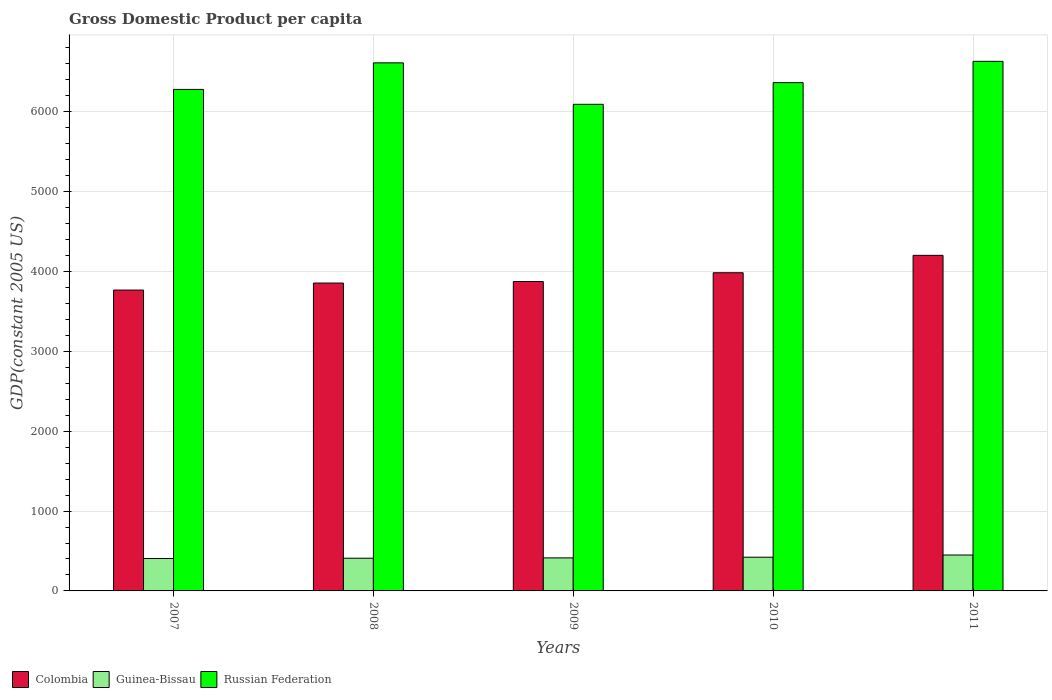How many bars are there on the 2nd tick from the right?
Your answer should be very brief. 3. What is the label of the 3rd group of bars from the left?
Your answer should be very brief. 2009. What is the GDP per capita in Guinea-Bissau in 2009?
Keep it short and to the point. 413.72. Across all years, what is the maximum GDP per capita in Russian Federation?
Your answer should be compact. 6631.46. Across all years, what is the minimum GDP per capita in Colombia?
Give a very brief answer. 3767.33. What is the total GDP per capita in Guinea-Bissau in the graph?
Make the answer very short. 2100.59. What is the difference between the GDP per capita in Colombia in 2008 and that in 2011?
Offer a very short reply. -346.98. What is the difference between the GDP per capita in Colombia in 2007 and the GDP per capita in Guinea-Bissau in 2009?
Offer a terse response. 3353.61. What is the average GDP per capita in Russian Federation per year?
Offer a very short reply. 6396.62. In the year 2010, what is the difference between the GDP per capita in Guinea-Bissau and GDP per capita in Colombia?
Keep it short and to the point. -3562.12. In how many years, is the GDP per capita in Russian Federation greater than 4600 US$?
Your response must be concise. 5. What is the ratio of the GDP per capita in Guinea-Bissau in 2007 to that in 2011?
Offer a terse response. 0.9. Is the difference between the GDP per capita in Guinea-Bissau in 2007 and 2011 greater than the difference between the GDP per capita in Colombia in 2007 and 2011?
Ensure brevity in your answer.  Yes. What is the difference between the highest and the second highest GDP per capita in Guinea-Bissau?
Offer a very short reply. 27.3. What is the difference between the highest and the lowest GDP per capita in Colombia?
Keep it short and to the point. 434.81. What does the 2nd bar from the left in 2009 represents?
Keep it short and to the point. Guinea-Bissau. What does the 2nd bar from the right in 2009 represents?
Make the answer very short. Guinea-Bissau. Is it the case that in every year, the sum of the GDP per capita in Colombia and GDP per capita in Russian Federation is greater than the GDP per capita in Guinea-Bissau?
Make the answer very short. Yes. How many bars are there?
Keep it short and to the point. 15. How many years are there in the graph?
Ensure brevity in your answer.  5. Does the graph contain any zero values?
Provide a succinct answer. No. How are the legend labels stacked?
Provide a succinct answer. Horizontal. What is the title of the graph?
Give a very brief answer. Gross Domestic Product per capita. Does "Malta" appear as one of the legend labels in the graph?
Ensure brevity in your answer.  No. What is the label or title of the X-axis?
Offer a very short reply. Years. What is the label or title of the Y-axis?
Offer a very short reply. GDP(constant 2005 US). What is the GDP(constant 2005 US) of Colombia in 2007?
Provide a succinct answer. 3767.33. What is the GDP(constant 2005 US) in Guinea-Bissau in 2007?
Your response must be concise. 405.66. What is the GDP(constant 2005 US) in Russian Federation in 2007?
Keep it short and to the point. 6280.15. What is the GDP(constant 2005 US) of Colombia in 2008?
Your response must be concise. 3855.16. What is the GDP(constant 2005 US) of Guinea-Bissau in 2008?
Your response must be concise. 409.56. What is the GDP(constant 2005 US) of Russian Federation in 2008?
Give a very brief answer. 6612.63. What is the GDP(constant 2005 US) in Colombia in 2009?
Your answer should be very brief. 3874.43. What is the GDP(constant 2005 US) in Guinea-Bissau in 2009?
Keep it short and to the point. 413.72. What is the GDP(constant 2005 US) in Russian Federation in 2009?
Keep it short and to the point. 6093.63. What is the GDP(constant 2005 US) of Colombia in 2010?
Your response must be concise. 3984.29. What is the GDP(constant 2005 US) in Guinea-Bissau in 2010?
Keep it short and to the point. 422.17. What is the GDP(constant 2005 US) in Russian Federation in 2010?
Ensure brevity in your answer.  6365.21. What is the GDP(constant 2005 US) in Colombia in 2011?
Keep it short and to the point. 4202.14. What is the GDP(constant 2005 US) of Guinea-Bissau in 2011?
Your response must be concise. 449.48. What is the GDP(constant 2005 US) of Russian Federation in 2011?
Your answer should be compact. 6631.46. Across all years, what is the maximum GDP(constant 2005 US) of Colombia?
Offer a very short reply. 4202.14. Across all years, what is the maximum GDP(constant 2005 US) in Guinea-Bissau?
Provide a succinct answer. 449.48. Across all years, what is the maximum GDP(constant 2005 US) of Russian Federation?
Offer a very short reply. 6631.46. Across all years, what is the minimum GDP(constant 2005 US) of Colombia?
Keep it short and to the point. 3767.33. Across all years, what is the minimum GDP(constant 2005 US) of Guinea-Bissau?
Make the answer very short. 405.66. Across all years, what is the minimum GDP(constant 2005 US) of Russian Federation?
Your answer should be very brief. 6093.63. What is the total GDP(constant 2005 US) of Colombia in the graph?
Your answer should be very brief. 1.97e+04. What is the total GDP(constant 2005 US) in Guinea-Bissau in the graph?
Keep it short and to the point. 2100.59. What is the total GDP(constant 2005 US) in Russian Federation in the graph?
Keep it short and to the point. 3.20e+04. What is the difference between the GDP(constant 2005 US) of Colombia in 2007 and that in 2008?
Make the answer very short. -87.83. What is the difference between the GDP(constant 2005 US) of Guinea-Bissau in 2007 and that in 2008?
Ensure brevity in your answer.  -3.9. What is the difference between the GDP(constant 2005 US) of Russian Federation in 2007 and that in 2008?
Your answer should be very brief. -332.48. What is the difference between the GDP(constant 2005 US) in Colombia in 2007 and that in 2009?
Provide a short and direct response. -107.1. What is the difference between the GDP(constant 2005 US) of Guinea-Bissau in 2007 and that in 2009?
Offer a terse response. -8.05. What is the difference between the GDP(constant 2005 US) of Russian Federation in 2007 and that in 2009?
Offer a very short reply. 186.52. What is the difference between the GDP(constant 2005 US) in Colombia in 2007 and that in 2010?
Your response must be concise. -216.96. What is the difference between the GDP(constant 2005 US) in Guinea-Bissau in 2007 and that in 2010?
Keep it short and to the point. -16.51. What is the difference between the GDP(constant 2005 US) of Russian Federation in 2007 and that in 2010?
Offer a very short reply. -85.07. What is the difference between the GDP(constant 2005 US) of Colombia in 2007 and that in 2011?
Keep it short and to the point. -434.81. What is the difference between the GDP(constant 2005 US) of Guinea-Bissau in 2007 and that in 2011?
Offer a terse response. -43.82. What is the difference between the GDP(constant 2005 US) of Russian Federation in 2007 and that in 2011?
Provide a short and direct response. -351.32. What is the difference between the GDP(constant 2005 US) of Colombia in 2008 and that in 2009?
Make the answer very short. -19.27. What is the difference between the GDP(constant 2005 US) in Guinea-Bissau in 2008 and that in 2009?
Provide a succinct answer. -4.16. What is the difference between the GDP(constant 2005 US) of Russian Federation in 2008 and that in 2009?
Keep it short and to the point. 519. What is the difference between the GDP(constant 2005 US) of Colombia in 2008 and that in 2010?
Provide a short and direct response. -129.13. What is the difference between the GDP(constant 2005 US) of Guinea-Bissau in 2008 and that in 2010?
Give a very brief answer. -12.61. What is the difference between the GDP(constant 2005 US) of Russian Federation in 2008 and that in 2010?
Make the answer very short. 247.42. What is the difference between the GDP(constant 2005 US) of Colombia in 2008 and that in 2011?
Your response must be concise. -346.98. What is the difference between the GDP(constant 2005 US) of Guinea-Bissau in 2008 and that in 2011?
Keep it short and to the point. -39.92. What is the difference between the GDP(constant 2005 US) of Russian Federation in 2008 and that in 2011?
Your answer should be very brief. -18.83. What is the difference between the GDP(constant 2005 US) in Colombia in 2009 and that in 2010?
Your answer should be compact. -109.86. What is the difference between the GDP(constant 2005 US) in Guinea-Bissau in 2009 and that in 2010?
Your response must be concise. -8.46. What is the difference between the GDP(constant 2005 US) of Russian Federation in 2009 and that in 2010?
Provide a short and direct response. -271.58. What is the difference between the GDP(constant 2005 US) of Colombia in 2009 and that in 2011?
Your answer should be compact. -327.72. What is the difference between the GDP(constant 2005 US) in Guinea-Bissau in 2009 and that in 2011?
Give a very brief answer. -35.76. What is the difference between the GDP(constant 2005 US) in Russian Federation in 2009 and that in 2011?
Offer a terse response. -537.83. What is the difference between the GDP(constant 2005 US) of Colombia in 2010 and that in 2011?
Ensure brevity in your answer.  -217.85. What is the difference between the GDP(constant 2005 US) of Guinea-Bissau in 2010 and that in 2011?
Ensure brevity in your answer.  -27.3. What is the difference between the GDP(constant 2005 US) of Russian Federation in 2010 and that in 2011?
Ensure brevity in your answer.  -266.25. What is the difference between the GDP(constant 2005 US) of Colombia in 2007 and the GDP(constant 2005 US) of Guinea-Bissau in 2008?
Keep it short and to the point. 3357.77. What is the difference between the GDP(constant 2005 US) in Colombia in 2007 and the GDP(constant 2005 US) in Russian Federation in 2008?
Provide a short and direct response. -2845.3. What is the difference between the GDP(constant 2005 US) in Guinea-Bissau in 2007 and the GDP(constant 2005 US) in Russian Federation in 2008?
Your response must be concise. -6206.97. What is the difference between the GDP(constant 2005 US) in Colombia in 2007 and the GDP(constant 2005 US) in Guinea-Bissau in 2009?
Your response must be concise. 3353.61. What is the difference between the GDP(constant 2005 US) in Colombia in 2007 and the GDP(constant 2005 US) in Russian Federation in 2009?
Offer a very short reply. -2326.3. What is the difference between the GDP(constant 2005 US) of Guinea-Bissau in 2007 and the GDP(constant 2005 US) of Russian Federation in 2009?
Your response must be concise. -5687.97. What is the difference between the GDP(constant 2005 US) of Colombia in 2007 and the GDP(constant 2005 US) of Guinea-Bissau in 2010?
Keep it short and to the point. 3345.16. What is the difference between the GDP(constant 2005 US) of Colombia in 2007 and the GDP(constant 2005 US) of Russian Federation in 2010?
Offer a terse response. -2597.88. What is the difference between the GDP(constant 2005 US) of Guinea-Bissau in 2007 and the GDP(constant 2005 US) of Russian Federation in 2010?
Make the answer very short. -5959.55. What is the difference between the GDP(constant 2005 US) in Colombia in 2007 and the GDP(constant 2005 US) in Guinea-Bissau in 2011?
Provide a short and direct response. 3317.85. What is the difference between the GDP(constant 2005 US) of Colombia in 2007 and the GDP(constant 2005 US) of Russian Federation in 2011?
Offer a terse response. -2864.13. What is the difference between the GDP(constant 2005 US) of Guinea-Bissau in 2007 and the GDP(constant 2005 US) of Russian Federation in 2011?
Ensure brevity in your answer.  -6225.8. What is the difference between the GDP(constant 2005 US) in Colombia in 2008 and the GDP(constant 2005 US) in Guinea-Bissau in 2009?
Your answer should be very brief. 3441.45. What is the difference between the GDP(constant 2005 US) in Colombia in 2008 and the GDP(constant 2005 US) in Russian Federation in 2009?
Keep it short and to the point. -2238.47. What is the difference between the GDP(constant 2005 US) in Guinea-Bissau in 2008 and the GDP(constant 2005 US) in Russian Federation in 2009?
Give a very brief answer. -5684.07. What is the difference between the GDP(constant 2005 US) in Colombia in 2008 and the GDP(constant 2005 US) in Guinea-Bissau in 2010?
Make the answer very short. 3432.99. What is the difference between the GDP(constant 2005 US) of Colombia in 2008 and the GDP(constant 2005 US) of Russian Federation in 2010?
Offer a very short reply. -2510.05. What is the difference between the GDP(constant 2005 US) in Guinea-Bissau in 2008 and the GDP(constant 2005 US) in Russian Federation in 2010?
Your answer should be very brief. -5955.65. What is the difference between the GDP(constant 2005 US) of Colombia in 2008 and the GDP(constant 2005 US) of Guinea-Bissau in 2011?
Provide a succinct answer. 3405.69. What is the difference between the GDP(constant 2005 US) of Colombia in 2008 and the GDP(constant 2005 US) of Russian Federation in 2011?
Ensure brevity in your answer.  -2776.3. What is the difference between the GDP(constant 2005 US) of Guinea-Bissau in 2008 and the GDP(constant 2005 US) of Russian Federation in 2011?
Keep it short and to the point. -6221.91. What is the difference between the GDP(constant 2005 US) in Colombia in 2009 and the GDP(constant 2005 US) in Guinea-Bissau in 2010?
Ensure brevity in your answer.  3452.26. What is the difference between the GDP(constant 2005 US) in Colombia in 2009 and the GDP(constant 2005 US) in Russian Federation in 2010?
Provide a succinct answer. -2490.78. What is the difference between the GDP(constant 2005 US) of Guinea-Bissau in 2009 and the GDP(constant 2005 US) of Russian Federation in 2010?
Your answer should be very brief. -5951.5. What is the difference between the GDP(constant 2005 US) in Colombia in 2009 and the GDP(constant 2005 US) in Guinea-Bissau in 2011?
Make the answer very short. 3424.95. What is the difference between the GDP(constant 2005 US) of Colombia in 2009 and the GDP(constant 2005 US) of Russian Federation in 2011?
Ensure brevity in your answer.  -2757.03. What is the difference between the GDP(constant 2005 US) of Guinea-Bissau in 2009 and the GDP(constant 2005 US) of Russian Federation in 2011?
Ensure brevity in your answer.  -6217.75. What is the difference between the GDP(constant 2005 US) in Colombia in 2010 and the GDP(constant 2005 US) in Guinea-Bissau in 2011?
Your answer should be very brief. 3534.81. What is the difference between the GDP(constant 2005 US) in Colombia in 2010 and the GDP(constant 2005 US) in Russian Federation in 2011?
Give a very brief answer. -2647.17. What is the difference between the GDP(constant 2005 US) in Guinea-Bissau in 2010 and the GDP(constant 2005 US) in Russian Federation in 2011?
Offer a very short reply. -6209.29. What is the average GDP(constant 2005 US) in Colombia per year?
Keep it short and to the point. 3936.67. What is the average GDP(constant 2005 US) in Guinea-Bissau per year?
Provide a succinct answer. 420.12. What is the average GDP(constant 2005 US) in Russian Federation per year?
Offer a very short reply. 6396.62. In the year 2007, what is the difference between the GDP(constant 2005 US) in Colombia and GDP(constant 2005 US) in Guinea-Bissau?
Make the answer very short. 3361.67. In the year 2007, what is the difference between the GDP(constant 2005 US) of Colombia and GDP(constant 2005 US) of Russian Federation?
Offer a very short reply. -2512.82. In the year 2007, what is the difference between the GDP(constant 2005 US) of Guinea-Bissau and GDP(constant 2005 US) of Russian Federation?
Keep it short and to the point. -5874.49. In the year 2008, what is the difference between the GDP(constant 2005 US) of Colombia and GDP(constant 2005 US) of Guinea-Bissau?
Keep it short and to the point. 3445.61. In the year 2008, what is the difference between the GDP(constant 2005 US) in Colombia and GDP(constant 2005 US) in Russian Federation?
Your answer should be compact. -2757.47. In the year 2008, what is the difference between the GDP(constant 2005 US) in Guinea-Bissau and GDP(constant 2005 US) in Russian Federation?
Make the answer very short. -6203.07. In the year 2009, what is the difference between the GDP(constant 2005 US) of Colombia and GDP(constant 2005 US) of Guinea-Bissau?
Offer a very short reply. 3460.71. In the year 2009, what is the difference between the GDP(constant 2005 US) of Colombia and GDP(constant 2005 US) of Russian Federation?
Your answer should be compact. -2219.2. In the year 2009, what is the difference between the GDP(constant 2005 US) of Guinea-Bissau and GDP(constant 2005 US) of Russian Federation?
Ensure brevity in your answer.  -5679.91. In the year 2010, what is the difference between the GDP(constant 2005 US) of Colombia and GDP(constant 2005 US) of Guinea-Bissau?
Provide a short and direct response. 3562.12. In the year 2010, what is the difference between the GDP(constant 2005 US) in Colombia and GDP(constant 2005 US) in Russian Federation?
Your response must be concise. -2380.92. In the year 2010, what is the difference between the GDP(constant 2005 US) in Guinea-Bissau and GDP(constant 2005 US) in Russian Federation?
Your response must be concise. -5943.04. In the year 2011, what is the difference between the GDP(constant 2005 US) in Colombia and GDP(constant 2005 US) in Guinea-Bissau?
Offer a very short reply. 3752.67. In the year 2011, what is the difference between the GDP(constant 2005 US) in Colombia and GDP(constant 2005 US) in Russian Federation?
Provide a short and direct response. -2429.32. In the year 2011, what is the difference between the GDP(constant 2005 US) in Guinea-Bissau and GDP(constant 2005 US) in Russian Federation?
Give a very brief answer. -6181.99. What is the ratio of the GDP(constant 2005 US) of Colombia in 2007 to that in 2008?
Ensure brevity in your answer.  0.98. What is the ratio of the GDP(constant 2005 US) in Guinea-Bissau in 2007 to that in 2008?
Your response must be concise. 0.99. What is the ratio of the GDP(constant 2005 US) of Russian Federation in 2007 to that in 2008?
Provide a short and direct response. 0.95. What is the ratio of the GDP(constant 2005 US) in Colombia in 2007 to that in 2009?
Provide a short and direct response. 0.97. What is the ratio of the GDP(constant 2005 US) in Guinea-Bissau in 2007 to that in 2009?
Your answer should be compact. 0.98. What is the ratio of the GDP(constant 2005 US) in Russian Federation in 2007 to that in 2009?
Keep it short and to the point. 1.03. What is the ratio of the GDP(constant 2005 US) of Colombia in 2007 to that in 2010?
Give a very brief answer. 0.95. What is the ratio of the GDP(constant 2005 US) in Guinea-Bissau in 2007 to that in 2010?
Offer a very short reply. 0.96. What is the ratio of the GDP(constant 2005 US) of Russian Federation in 2007 to that in 2010?
Ensure brevity in your answer.  0.99. What is the ratio of the GDP(constant 2005 US) of Colombia in 2007 to that in 2011?
Give a very brief answer. 0.9. What is the ratio of the GDP(constant 2005 US) of Guinea-Bissau in 2007 to that in 2011?
Provide a short and direct response. 0.9. What is the ratio of the GDP(constant 2005 US) in Russian Federation in 2007 to that in 2011?
Make the answer very short. 0.95. What is the ratio of the GDP(constant 2005 US) of Russian Federation in 2008 to that in 2009?
Offer a terse response. 1.09. What is the ratio of the GDP(constant 2005 US) of Colombia in 2008 to that in 2010?
Your response must be concise. 0.97. What is the ratio of the GDP(constant 2005 US) in Guinea-Bissau in 2008 to that in 2010?
Provide a succinct answer. 0.97. What is the ratio of the GDP(constant 2005 US) in Russian Federation in 2008 to that in 2010?
Give a very brief answer. 1.04. What is the ratio of the GDP(constant 2005 US) in Colombia in 2008 to that in 2011?
Provide a succinct answer. 0.92. What is the ratio of the GDP(constant 2005 US) in Guinea-Bissau in 2008 to that in 2011?
Provide a short and direct response. 0.91. What is the ratio of the GDP(constant 2005 US) of Colombia in 2009 to that in 2010?
Your answer should be compact. 0.97. What is the ratio of the GDP(constant 2005 US) of Russian Federation in 2009 to that in 2010?
Your answer should be compact. 0.96. What is the ratio of the GDP(constant 2005 US) in Colombia in 2009 to that in 2011?
Your answer should be very brief. 0.92. What is the ratio of the GDP(constant 2005 US) of Guinea-Bissau in 2009 to that in 2011?
Provide a short and direct response. 0.92. What is the ratio of the GDP(constant 2005 US) of Russian Federation in 2009 to that in 2011?
Give a very brief answer. 0.92. What is the ratio of the GDP(constant 2005 US) in Colombia in 2010 to that in 2011?
Your answer should be compact. 0.95. What is the ratio of the GDP(constant 2005 US) in Guinea-Bissau in 2010 to that in 2011?
Make the answer very short. 0.94. What is the ratio of the GDP(constant 2005 US) of Russian Federation in 2010 to that in 2011?
Keep it short and to the point. 0.96. What is the difference between the highest and the second highest GDP(constant 2005 US) in Colombia?
Provide a short and direct response. 217.85. What is the difference between the highest and the second highest GDP(constant 2005 US) of Guinea-Bissau?
Ensure brevity in your answer.  27.3. What is the difference between the highest and the second highest GDP(constant 2005 US) of Russian Federation?
Offer a very short reply. 18.83. What is the difference between the highest and the lowest GDP(constant 2005 US) in Colombia?
Ensure brevity in your answer.  434.81. What is the difference between the highest and the lowest GDP(constant 2005 US) in Guinea-Bissau?
Provide a short and direct response. 43.82. What is the difference between the highest and the lowest GDP(constant 2005 US) in Russian Federation?
Ensure brevity in your answer.  537.83. 